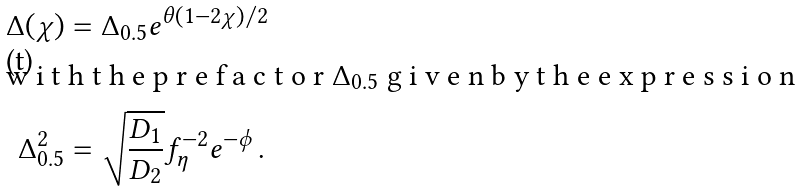<formula> <loc_0><loc_0><loc_500><loc_500>\Delta ( \chi ) & = \Delta _ { 0 . 5 } e ^ { \theta ( 1 - 2 \chi ) / 2 } \\ \intertext { w i t h t h e p r e f a c t o r $ \Delta _ { 0 . 5 } $ g i v e n b y t h e e x p r e s s i o n } \Delta _ { 0 . 5 } ^ { 2 } & = \sqrt { \frac { D _ { 1 } } { D _ { 2 } } } f _ { \eta } ^ { - 2 } e ^ { - \phi } \, .</formula> 